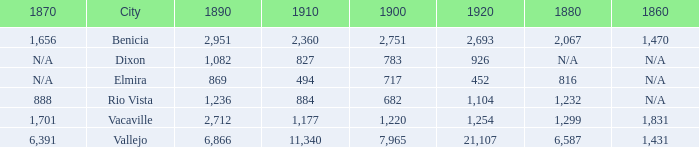What is the 1880 figure when 1860 is N/A and 1910 is 494? 816.0. 